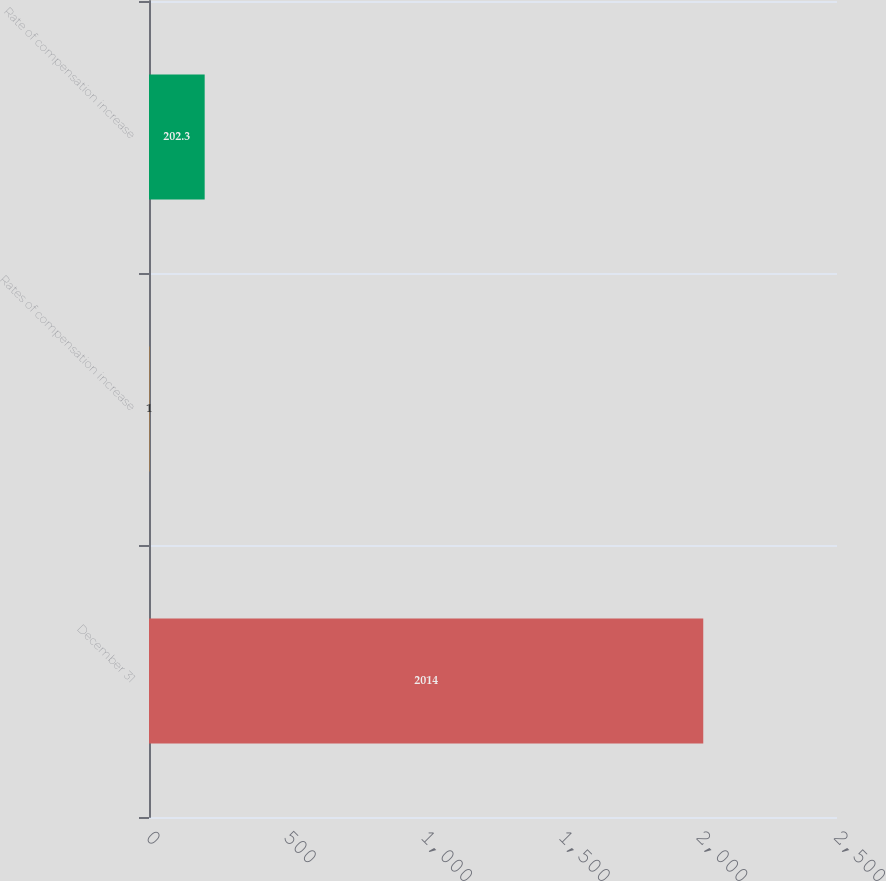<chart> <loc_0><loc_0><loc_500><loc_500><bar_chart><fcel>December 31<fcel>Rates of compensation increase<fcel>Rate of compensation increase<nl><fcel>2014<fcel>1<fcel>202.3<nl></chart> 